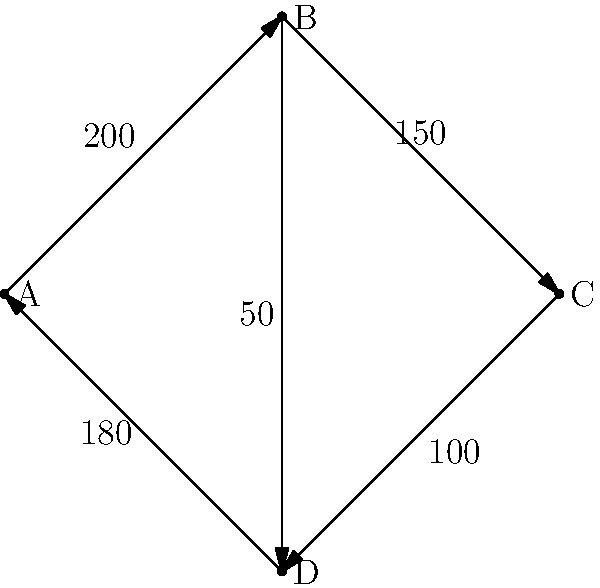Given the directed graph representing traffic flow through major intersections in our city, where each vertex represents an intersection and each edge represents a one-way street with its corresponding hourly vehicle count, what is the total number of vehicles entering intersection C per hour? How might this information influence our decision-making process regarding AI-assisted traffic management systems? To solve this problem, we need to follow these steps:

1. Identify the vertex representing intersection C in the graph.
2. Locate all edges directed towards intersection C.
3. Sum up the traffic flow values on these incoming edges.

Step 1: In the given graph, vertex C is located at the top right.

Step 2: There is only one edge directed towards intersection C, which is the edge from intersection B to C.

Step 3: The traffic flow value on the edge from B to C is 150 vehicles per hour.

Therefore, the total number of vehicles entering intersection C per hour is 150.

Regarding the influence on decision-making for AI-assisted traffic management:

1. This data provides a baseline for current traffic patterns, which is crucial for assessing the potential impact of AI systems.
2. The relatively low traffic flow (150 vehicles/hour) at this intersection might suggest that complex AI solutions could be unnecessary or cost-ineffective for this particular location.
3. However, we should consider that this is just one data point in a larger network. AI systems could potentially optimize traffic flow across the entire network, not just at individual intersections.
4. The ethical implications of implementing AI in traffic management, such as data privacy and potential biases in the system, should be carefully evaluated against the potential benefits of improved traffic flow.
5. It's important to consider how AI might adapt to changing traffic patterns over time, and whether it can outperform human-managed systems in the long term.

This data and analysis provide a starting point for a more comprehensive discussion on the feasibility and ethics of AI in urban planning, particularly in traffic management.
Answer: 150 vehicles per hour 